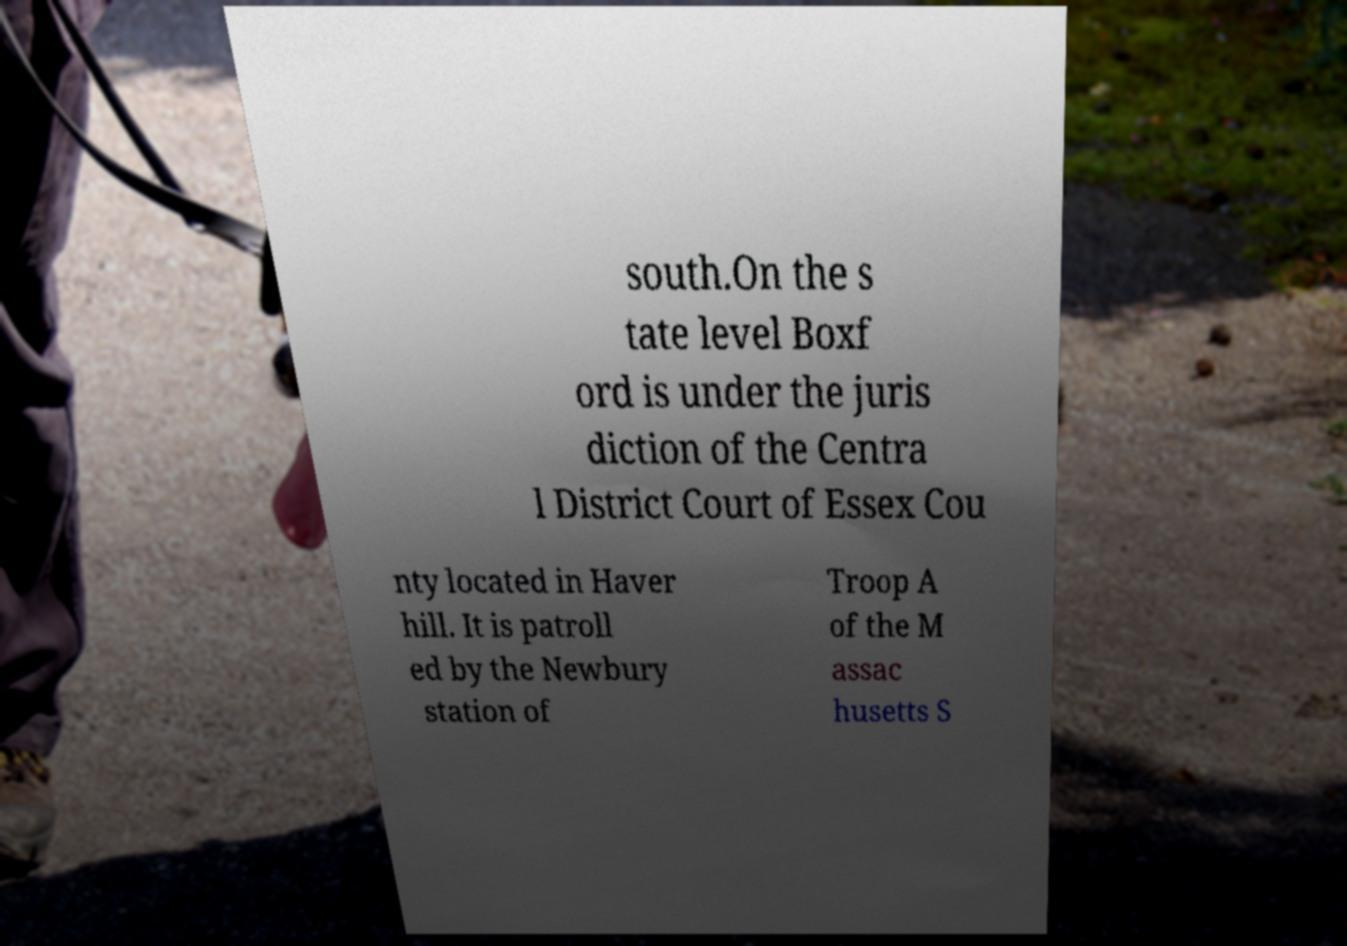I need the written content from this picture converted into text. Can you do that? south.On the s tate level Boxf ord is under the juris diction of the Centra l District Court of Essex Cou nty located in Haver hill. It is patroll ed by the Newbury station of Troop A of the M assac husetts S 